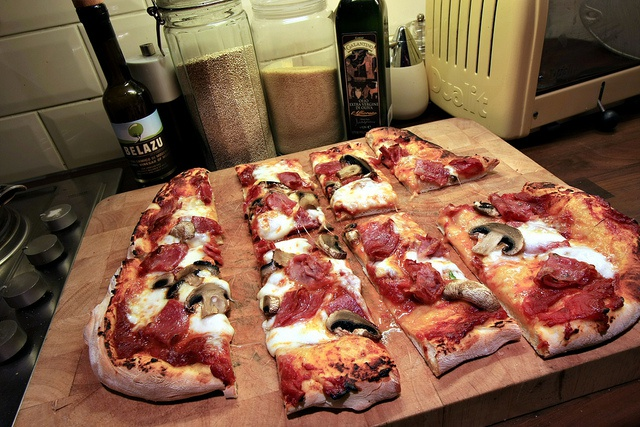Describe the objects in this image and their specific colors. I can see oven in gray, black, tan, and maroon tones, pizza in gray, maroon, brown, and tan tones, pizza in gray, tan, brown, and maroon tones, pizza in gray, brown, tan, and ivory tones, and pizza in gray, brown, tan, and maroon tones in this image. 